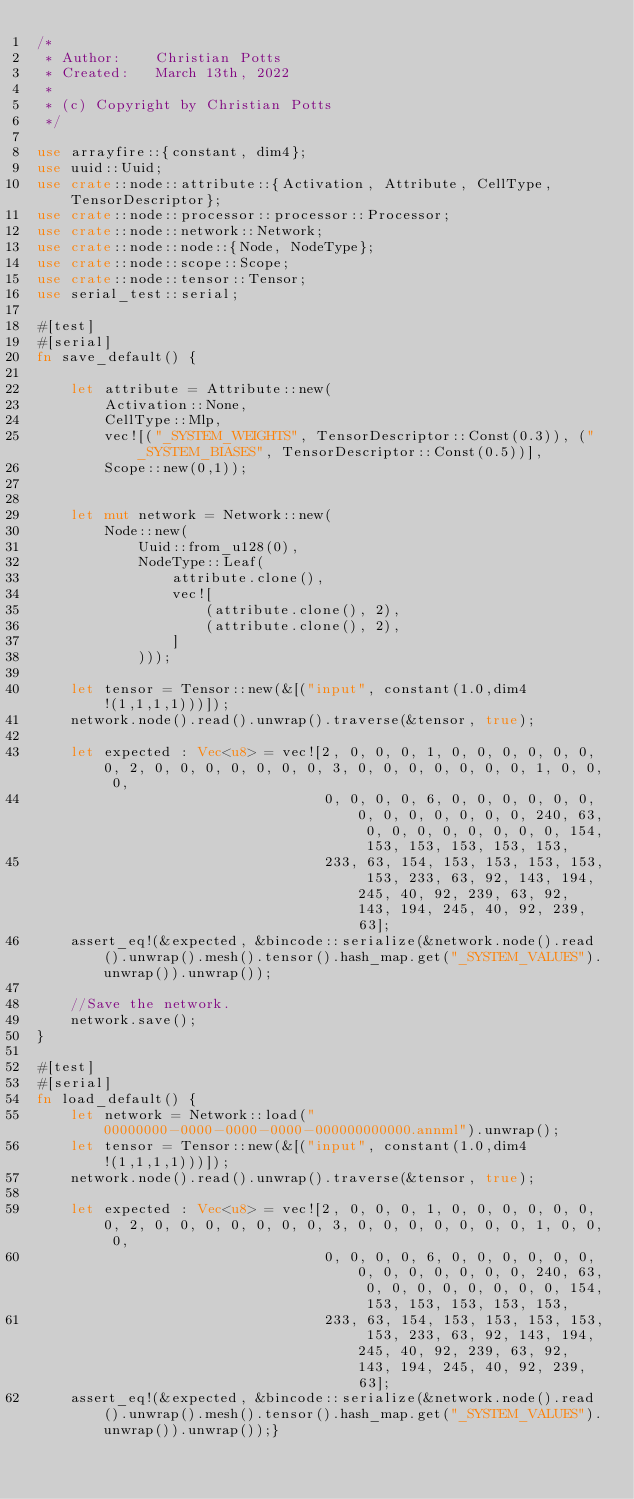<code> <loc_0><loc_0><loc_500><loc_500><_Rust_>/*
 * Author:    Christian Potts
 * Created:   March 13th, 2022
 *
 * (c) Copyright by Christian Potts
 */

use arrayfire::{constant, dim4};
use uuid::Uuid;
use crate::node::attribute::{Activation, Attribute, CellType, TensorDescriptor};
use crate::node::processor::processor::Processor;
use crate::node::network::Network;
use crate::node::node::{Node, NodeType};
use crate::node::scope::Scope;
use crate::node::tensor::Tensor;
use serial_test::serial;

#[test]
#[serial]
fn save_default() {

    let attribute = Attribute::new(
        Activation::None,
        CellType::Mlp,
        vec![("_SYSTEM_WEIGHTS", TensorDescriptor::Const(0.3)), ("_SYSTEM_BIASES", TensorDescriptor::Const(0.5))],
        Scope::new(0,1));


    let mut network = Network::new(
        Node::new(
            Uuid::from_u128(0),
            NodeType::Leaf(
                attribute.clone(),
                vec![
                    (attribute.clone(), 2),
                    (attribute.clone(), 2),
                ]
            )));

    let tensor = Tensor::new(&[("input", constant(1.0,dim4!(1,1,1,1)))]);
    network.node().read().unwrap().traverse(&tensor, true);

    let expected : Vec<u8> = vec![2, 0, 0, 0, 1, 0, 0, 0, 0, 0, 0, 0, 2, 0, 0, 0, 0, 0, 0, 0, 3, 0, 0, 0, 0, 0, 0, 0, 1, 0, 0, 0,
                                  0, 0, 0, 0, 6, 0, 0, 0, 0, 0, 0, 0, 0, 0, 0, 0, 0, 0, 240, 63, 0, 0, 0, 0, 0, 0, 0, 0, 154, 153, 153, 153, 153, 153,
                                  233, 63, 154, 153, 153, 153, 153, 153, 233, 63, 92, 143, 194, 245, 40, 92, 239, 63, 92, 143, 194, 245, 40, 92, 239, 63];
    assert_eq!(&expected, &bincode::serialize(&network.node().read().unwrap().mesh().tensor().hash_map.get("_SYSTEM_VALUES").unwrap()).unwrap());

    //Save the network.
    network.save();
}

#[test]
#[serial]
fn load_default() {
    let network = Network::load("00000000-0000-0000-0000-000000000000.annml").unwrap();
    let tensor = Tensor::new(&[("input", constant(1.0,dim4!(1,1,1,1)))]);
    network.node().read().unwrap().traverse(&tensor, true);

    let expected : Vec<u8> = vec![2, 0, 0, 0, 1, 0, 0, 0, 0, 0, 0, 0, 2, 0, 0, 0, 0, 0, 0, 0, 3, 0, 0, 0, 0, 0, 0, 0, 1, 0, 0, 0,
                                  0, 0, 0, 0, 6, 0, 0, 0, 0, 0, 0, 0, 0, 0, 0, 0, 0, 0, 240, 63, 0, 0, 0, 0, 0, 0, 0, 0, 154, 153, 153, 153, 153, 153,
                                  233, 63, 154, 153, 153, 153, 153, 153, 233, 63, 92, 143, 194, 245, 40, 92, 239, 63, 92, 143, 194, 245, 40, 92, 239, 63];
    assert_eq!(&expected, &bincode::serialize(&network.node().read().unwrap().mesh().tensor().hash_map.get("_SYSTEM_VALUES").unwrap()).unwrap());}</code> 